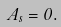Convert formula to latex. <formula><loc_0><loc_0><loc_500><loc_500>A _ { s } = 0 .</formula> 